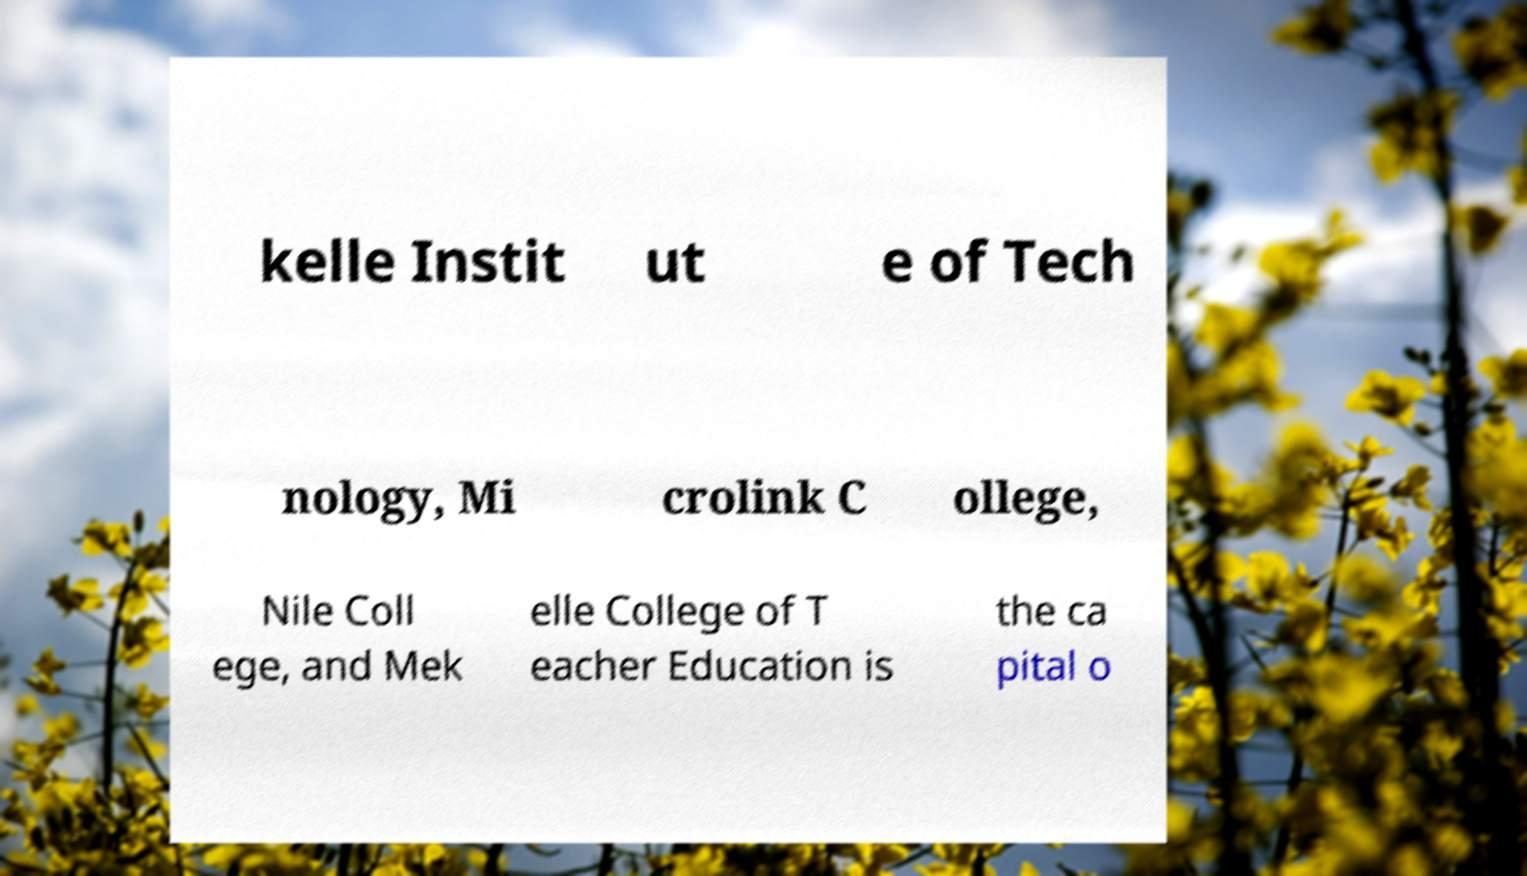What messages or text are displayed in this image? I need them in a readable, typed format. kelle Instit ut e of Tech nology, Mi crolink C ollege, Nile Coll ege, and Mek elle College of T eacher Education is the ca pital o 